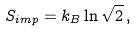<formula> <loc_0><loc_0><loc_500><loc_500>S _ { i m p } = k _ { B } \ln \sqrt { 2 } \, ,</formula> 